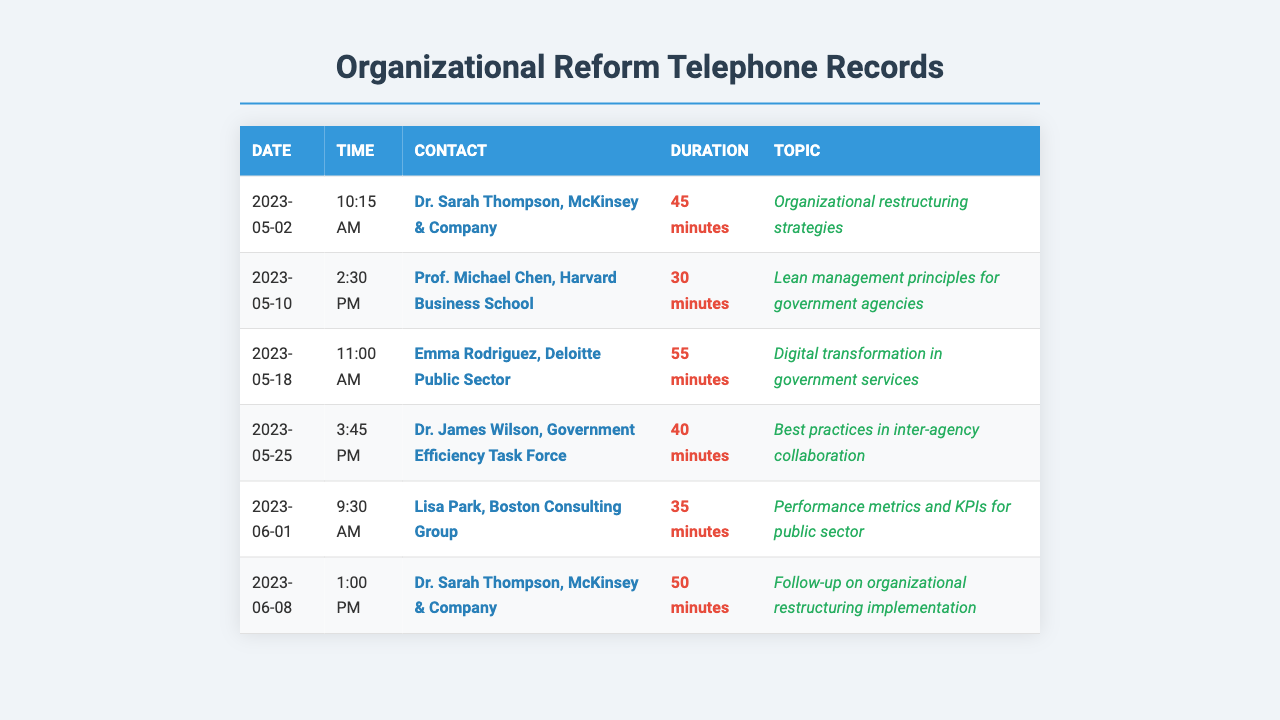What is the date of the call with Dr. Sarah Thompson? The document lists a call with Dr. Sarah Thompson on 2023-05-02 and another on 2023-06-08.
Answer: 2023-05-02 Who did Lisa Park represent during her call? Lisa Park is associated with the Boston Consulting Group, as indicated in the document.
Answer: Boston Consulting Group What was the duration of the call with Emma Rodriguez? The document shows that the call with Emma Rodriguez lasted for 55 minutes.
Answer: 55 minutes How many times was Dr. Sarah Thompson contacted? Dr. Sarah Thompson is listed twice in the document, indicating two separate calls.
Answer: Twice What topic was discussed in the call with Prof. Michael Chen? The document specifies that the topic discussed was "Lean management principles for government agencies."
Answer: Lean management principles for government agencies Which contact's call lasted the shortest time? The document records the shortest call as being with Lisa Park, lasting 35 minutes.
Answer: 35 minutes What time was the call with Dr. James Wilson made? The call with Dr. James Wilson was made at 3:45 PM, as per the recorded information.
Answer: 3:45 PM What is the primary topic of the last call listed? The last call listed in the document is focused on "Follow-up on organizational restructuring implementation."
Answer: Follow-up on organizational restructuring implementation 